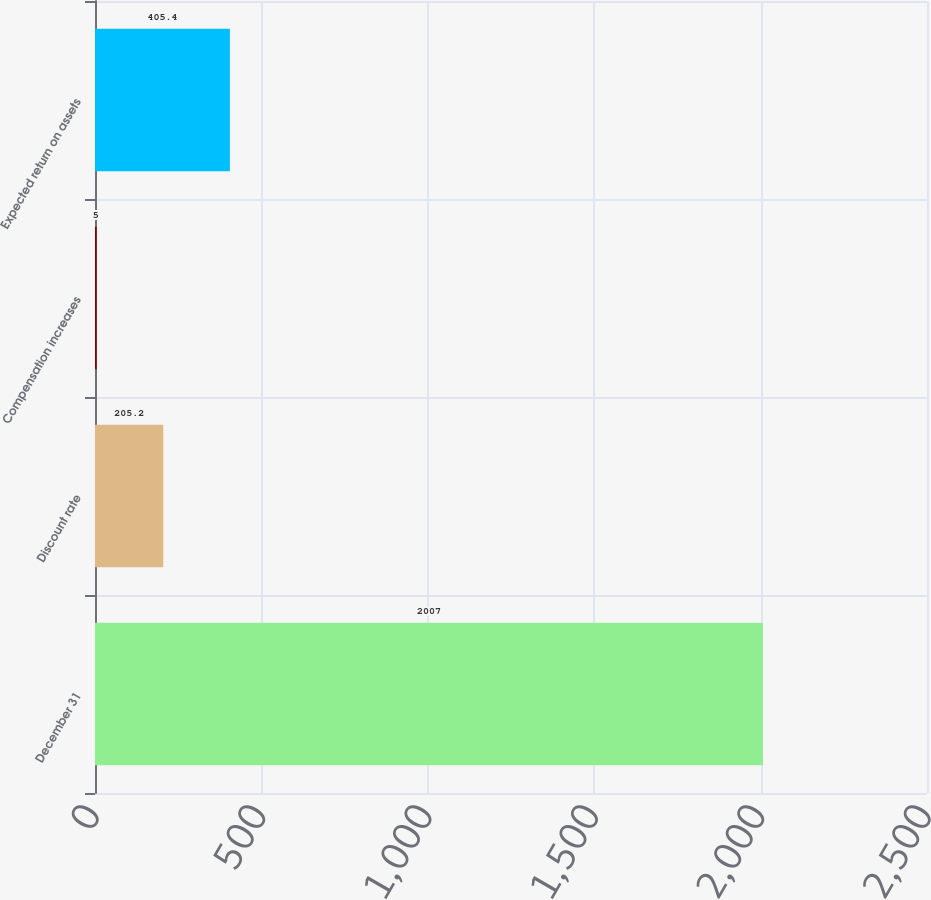Convert chart. <chart><loc_0><loc_0><loc_500><loc_500><bar_chart><fcel>December 31<fcel>Discount rate<fcel>Compensation increases<fcel>Expected return on assets<nl><fcel>2007<fcel>205.2<fcel>5<fcel>405.4<nl></chart> 